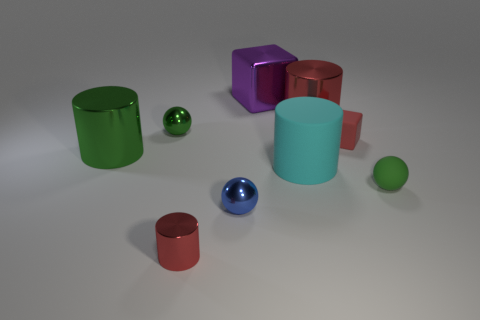Subtract all small green rubber spheres. How many spheres are left? 2 Add 1 large cyan matte cubes. How many objects exist? 10 Subtract all red cubes. How many cubes are left? 1 Subtract all purple cylinders. How many green spheres are left? 2 Subtract all cubes. How many objects are left? 7 Subtract 3 cylinders. How many cylinders are left? 1 Add 4 small spheres. How many small spheres are left? 7 Add 4 big cyan things. How many big cyan things exist? 5 Subtract 0 purple spheres. How many objects are left? 9 Subtract all purple blocks. Subtract all green cylinders. How many blocks are left? 1 